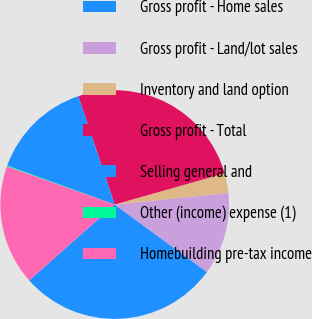Convert chart to OTSL. <chart><loc_0><loc_0><loc_500><loc_500><pie_chart><fcel>Gross profit - Home sales<fcel>Gross profit - Land/lot sales<fcel>Inventory and land option<fcel>Gross profit - Total<fcel>Selling general and<fcel>Other (income) expense (1)<fcel>Homebuilding pre-tax income<nl><fcel>28.4%<fcel>11.67%<fcel>2.78%<fcel>25.75%<fcel>14.31%<fcel>0.13%<fcel>16.96%<nl></chart> 